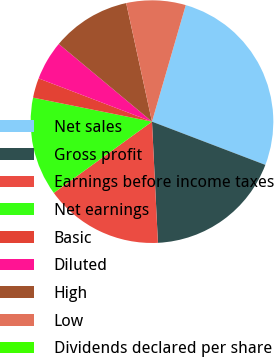Convert chart. <chart><loc_0><loc_0><loc_500><loc_500><pie_chart><fcel>Net sales<fcel>Gross profit<fcel>Earnings before income taxes<fcel>Net earnings<fcel>Basic<fcel>Diluted<fcel>High<fcel>Low<fcel>Dividends declared per share<nl><fcel>26.31%<fcel>18.42%<fcel>15.79%<fcel>13.16%<fcel>2.63%<fcel>5.26%<fcel>10.53%<fcel>7.9%<fcel>0.0%<nl></chart> 